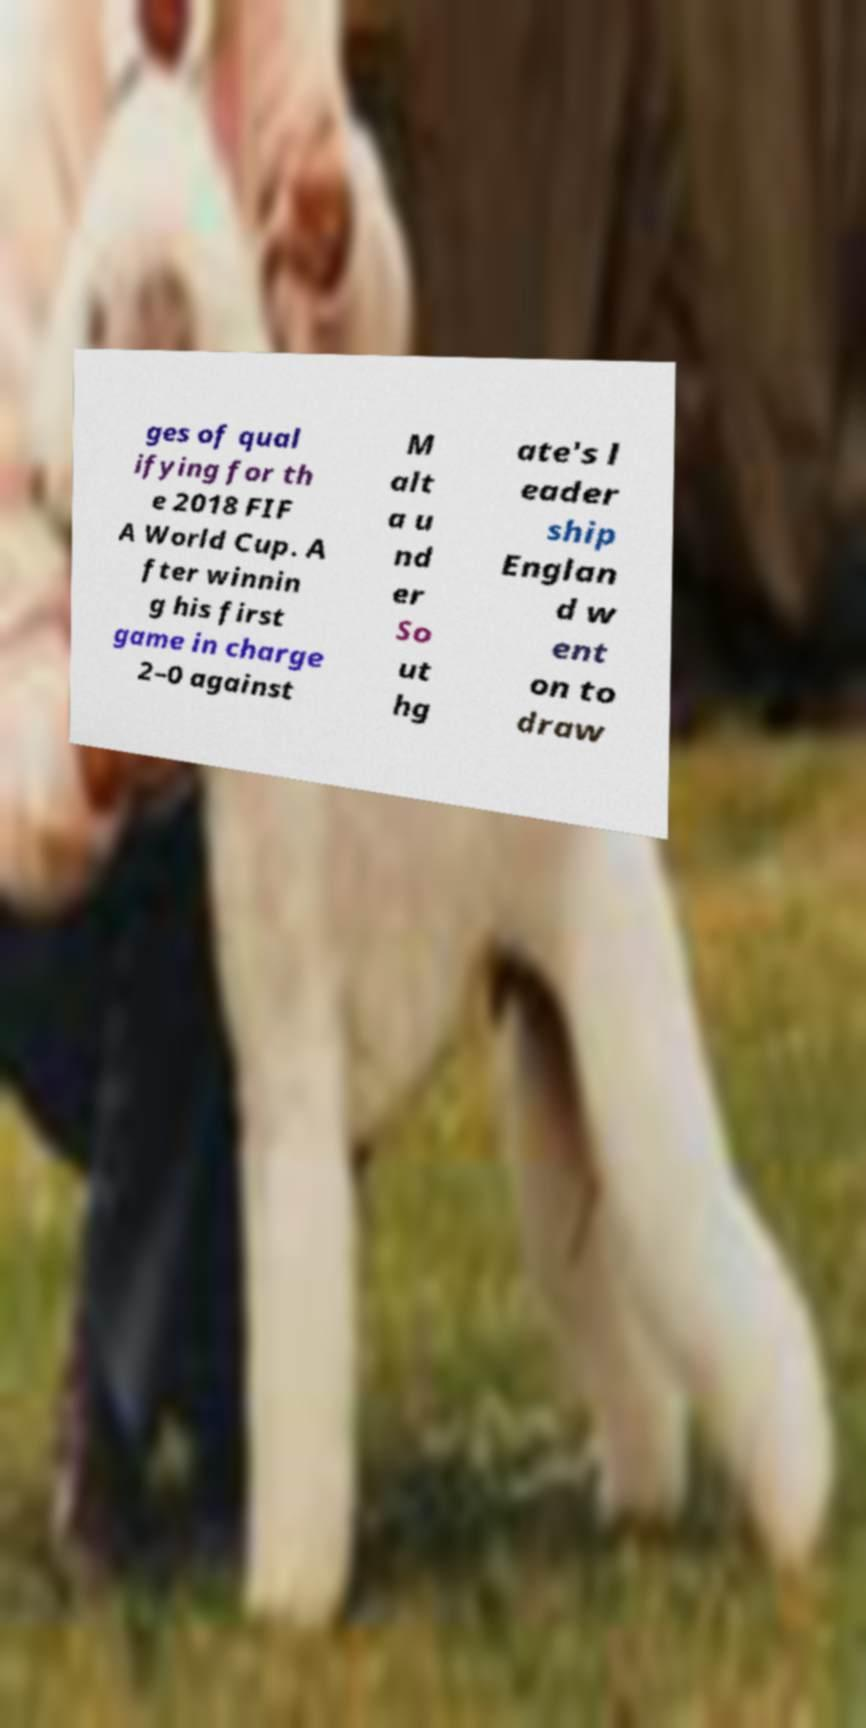What messages or text are displayed in this image? I need them in a readable, typed format. ges of qual ifying for th e 2018 FIF A World Cup. A fter winnin g his first game in charge 2–0 against M alt a u nd er So ut hg ate's l eader ship Englan d w ent on to draw 